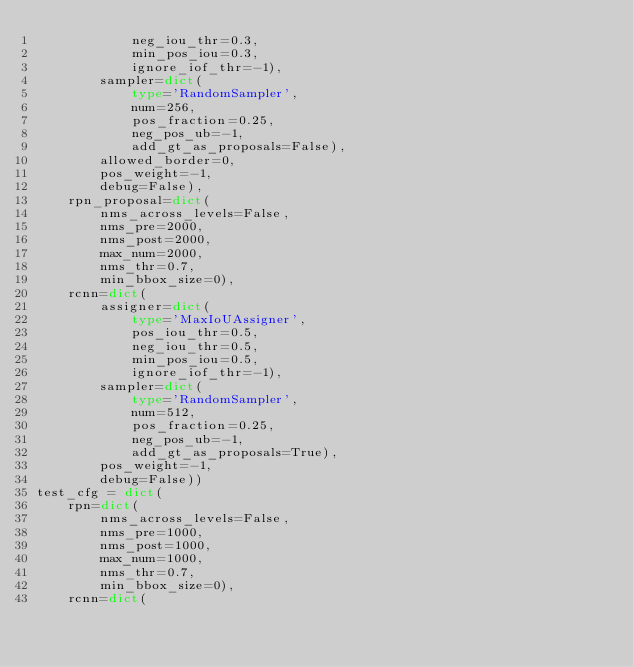Convert code to text. <code><loc_0><loc_0><loc_500><loc_500><_Python_>            neg_iou_thr=0.3,
            min_pos_iou=0.3,
            ignore_iof_thr=-1),
        sampler=dict(
            type='RandomSampler',
            num=256,
            pos_fraction=0.25,
            neg_pos_ub=-1,
            add_gt_as_proposals=False),
        allowed_border=0,
        pos_weight=-1,
        debug=False),
    rpn_proposal=dict(
        nms_across_levels=False,
        nms_pre=2000,
        nms_post=2000,
        max_num=2000,
        nms_thr=0.7,
        min_bbox_size=0),
    rcnn=dict(
        assigner=dict(
            type='MaxIoUAssigner',
            pos_iou_thr=0.5,
            neg_iou_thr=0.5,
            min_pos_iou=0.5,
            ignore_iof_thr=-1),
        sampler=dict(
            type='RandomSampler',
            num=512,
            pos_fraction=0.25,
            neg_pos_ub=-1,
            add_gt_as_proposals=True),
        pos_weight=-1,
        debug=False))
test_cfg = dict(
    rpn=dict(
        nms_across_levels=False,
        nms_pre=1000,
        nms_post=1000,
        max_num=1000,
        nms_thr=0.7,
        min_bbox_size=0),
    rcnn=dict(</code> 